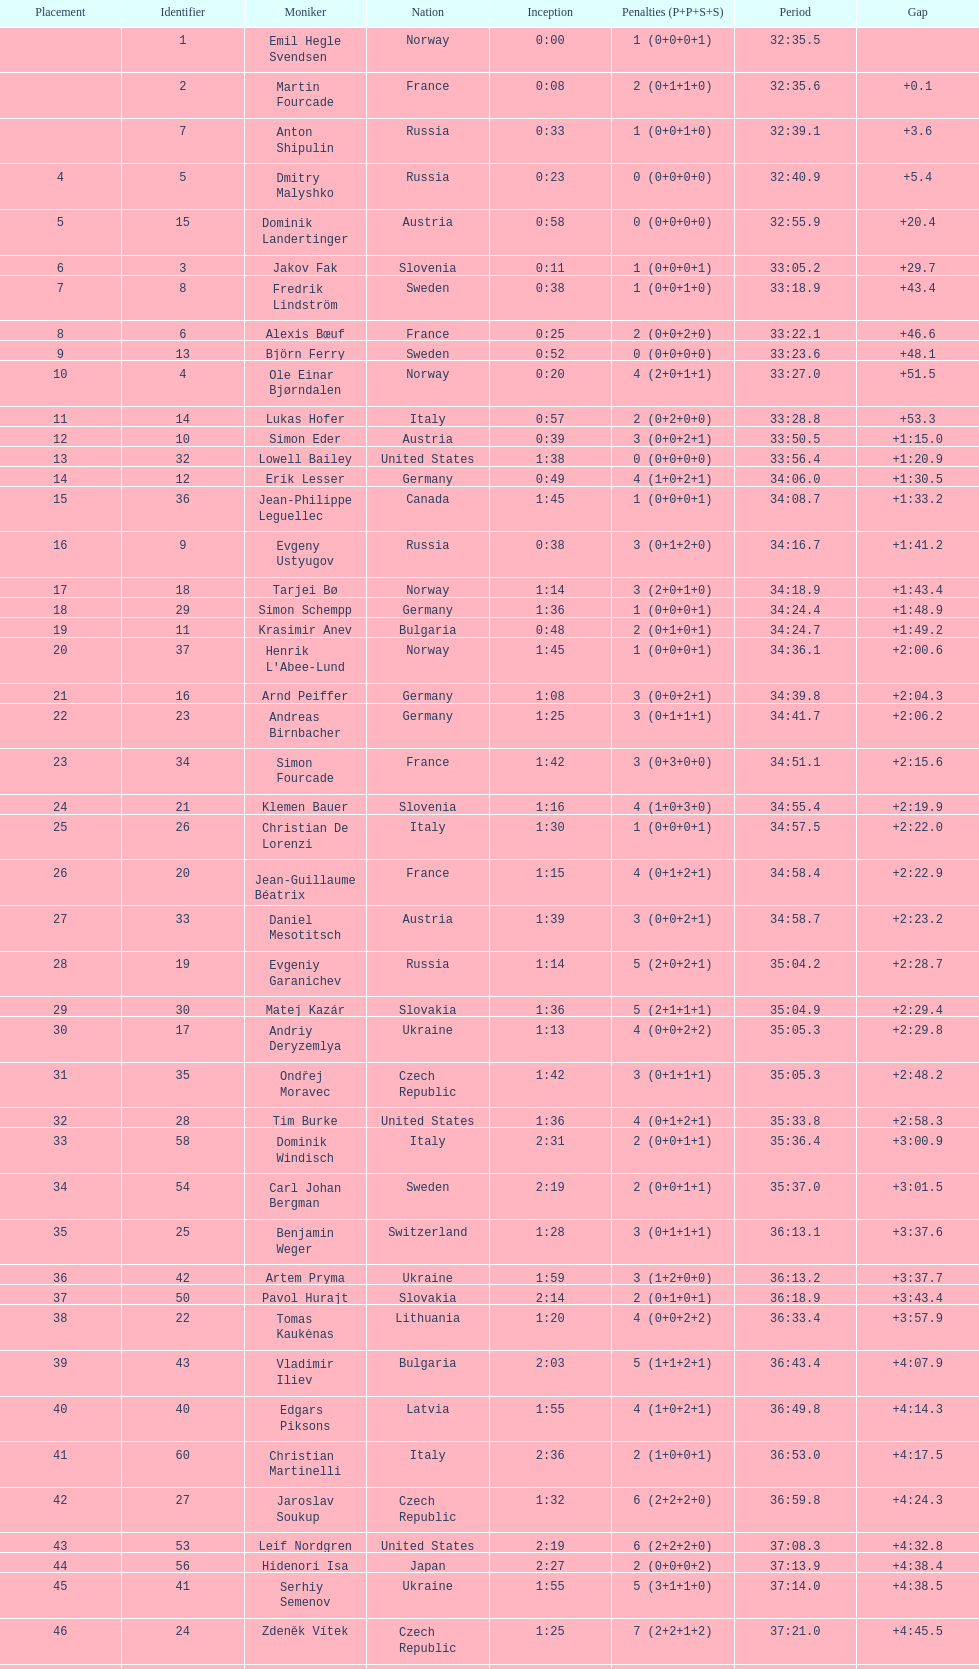What were the total number of "ties" (people who finished with the exact same time?) 2. 